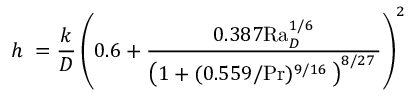<formula> <loc_0><loc_0><loc_500><loc_500>h \ = { \frac { k } { D } } \left ( { 0 . 6 + { \frac { 0 . 3 8 7 R a _ { D } ^ { 1 / 6 } } { \left ( 1 + ( 0 . 5 5 9 / P r ) ^ { 9 / 1 6 } \, \right ) ^ { 8 / 2 7 } \, } } } \right ) ^ { 2 }</formula> 